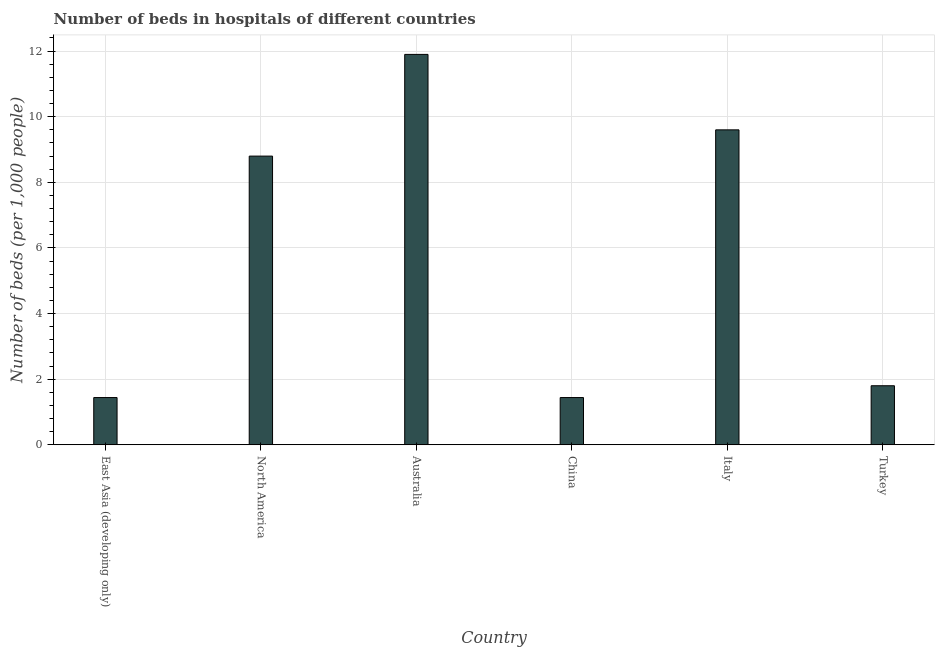Does the graph contain any zero values?
Ensure brevity in your answer.  No. What is the title of the graph?
Offer a very short reply. Number of beds in hospitals of different countries. What is the label or title of the X-axis?
Offer a very short reply. Country. What is the label or title of the Y-axis?
Ensure brevity in your answer.  Number of beds (per 1,0 people). What is the number of hospital beds in East Asia (developing only)?
Provide a short and direct response. 1.44. Across all countries, what is the maximum number of hospital beds?
Ensure brevity in your answer.  11.9. Across all countries, what is the minimum number of hospital beds?
Your answer should be compact. 1.44. In which country was the number of hospital beds minimum?
Your answer should be very brief. East Asia (developing only). What is the sum of the number of hospital beds?
Give a very brief answer. 34.98. What is the difference between the number of hospital beds in China and North America?
Provide a short and direct response. -7.36. What is the average number of hospital beds per country?
Your response must be concise. 5.83. What is the median number of hospital beds?
Ensure brevity in your answer.  5.3. What is the ratio of the number of hospital beds in East Asia (developing only) to that in North America?
Provide a short and direct response. 0.16. Is the number of hospital beds in Australia less than that in Italy?
Provide a short and direct response. No. Is the difference between the number of hospital beds in East Asia (developing only) and Turkey greater than the difference between any two countries?
Offer a very short reply. No. What is the difference between the highest and the lowest number of hospital beds?
Offer a terse response. 10.46. In how many countries, is the number of hospital beds greater than the average number of hospital beds taken over all countries?
Keep it short and to the point. 3. How many bars are there?
Ensure brevity in your answer.  6. How many countries are there in the graph?
Keep it short and to the point. 6. What is the difference between two consecutive major ticks on the Y-axis?
Offer a very short reply. 2. Are the values on the major ticks of Y-axis written in scientific E-notation?
Offer a very short reply. No. What is the Number of beds (per 1,000 people) in East Asia (developing only)?
Offer a very short reply. 1.44. What is the Number of beds (per 1,000 people) of North America?
Ensure brevity in your answer.  8.8. What is the Number of beds (per 1,000 people) in Australia?
Offer a terse response. 11.9. What is the Number of beds (per 1,000 people) of China?
Provide a succinct answer. 1.44. What is the Number of beds (per 1,000 people) of Italy?
Offer a terse response. 9.6. What is the Number of beds (per 1,000 people) of Turkey?
Provide a short and direct response. 1.8. What is the difference between the Number of beds (per 1,000 people) in East Asia (developing only) and North America?
Make the answer very short. -7.36. What is the difference between the Number of beds (per 1,000 people) in East Asia (developing only) and Australia?
Provide a short and direct response. -10.46. What is the difference between the Number of beds (per 1,000 people) in East Asia (developing only) and Italy?
Make the answer very short. -8.16. What is the difference between the Number of beds (per 1,000 people) in East Asia (developing only) and Turkey?
Your answer should be very brief. -0.36. What is the difference between the Number of beds (per 1,000 people) in North America and China?
Your answer should be very brief. 7.36. What is the difference between the Number of beds (per 1,000 people) in North America and Italy?
Give a very brief answer. -0.8. What is the difference between the Number of beds (per 1,000 people) in North America and Turkey?
Keep it short and to the point. 7. What is the difference between the Number of beds (per 1,000 people) in Australia and China?
Ensure brevity in your answer.  10.46. What is the difference between the Number of beds (per 1,000 people) in Australia and Italy?
Your response must be concise. 2.3. What is the difference between the Number of beds (per 1,000 people) in China and Italy?
Give a very brief answer. -8.16. What is the difference between the Number of beds (per 1,000 people) in China and Turkey?
Your response must be concise. -0.36. What is the ratio of the Number of beds (per 1,000 people) in East Asia (developing only) to that in North America?
Ensure brevity in your answer.  0.16. What is the ratio of the Number of beds (per 1,000 people) in East Asia (developing only) to that in Australia?
Provide a short and direct response. 0.12. What is the ratio of the Number of beds (per 1,000 people) in East Asia (developing only) to that in China?
Your answer should be compact. 1. What is the ratio of the Number of beds (per 1,000 people) in East Asia (developing only) to that in Turkey?
Provide a succinct answer. 0.8. What is the ratio of the Number of beds (per 1,000 people) in North America to that in Australia?
Keep it short and to the point. 0.74. What is the ratio of the Number of beds (per 1,000 people) in North America to that in China?
Your answer should be very brief. 6.11. What is the ratio of the Number of beds (per 1,000 people) in North America to that in Italy?
Your answer should be very brief. 0.92. What is the ratio of the Number of beds (per 1,000 people) in North America to that in Turkey?
Your answer should be very brief. 4.89. What is the ratio of the Number of beds (per 1,000 people) in Australia to that in China?
Your answer should be very brief. 8.26. What is the ratio of the Number of beds (per 1,000 people) in Australia to that in Italy?
Ensure brevity in your answer.  1.24. What is the ratio of the Number of beds (per 1,000 people) in Australia to that in Turkey?
Provide a succinct answer. 6.61. What is the ratio of the Number of beds (per 1,000 people) in China to that in Italy?
Offer a terse response. 0.15. What is the ratio of the Number of beds (per 1,000 people) in China to that in Turkey?
Keep it short and to the point. 0.8. What is the ratio of the Number of beds (per 1,000 people) in Italy to that in Turkey?
Offer a terse response. 5.33. 